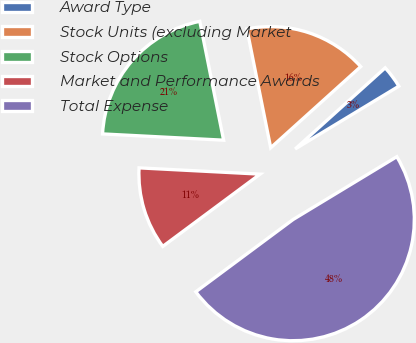Convert chart. <chart><loc_0><loc_0><loc_500><loc_500><pie_chart><fcel>Award Type<fcel>Stock Units (excluding Market<fcel>Stock Options<fcel>Market and Performance Awards<fcel>Total Expense<nl><fcel>3.01%<fcel>16.47%<fcel>21.03%<fcel>10.99%<fcel>48.5%<nl></chart> 